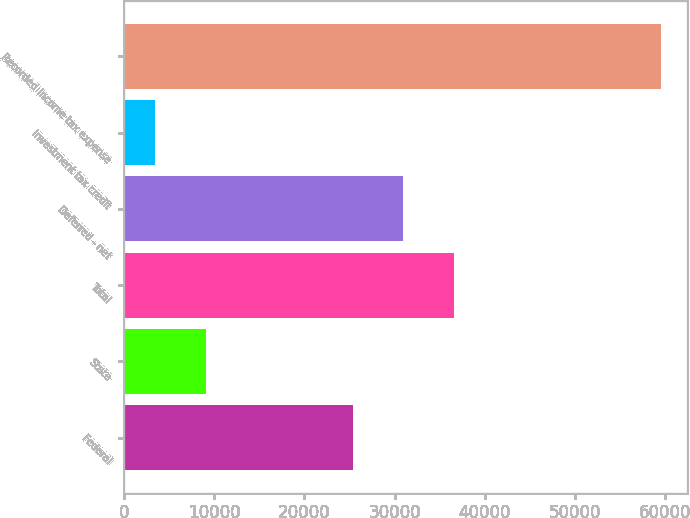Convert chart to OTSL. <chart><loc_0><loc_0><loc_500><loc_500><bar_chart><fcel>Federal<fcel>State<fcel>Total<fcel>Deferred - net<fcel>Investment tax credit<fcel>Recorded income tax expense<nl><fcel>25356<fcel>9081.4<fcel>36558.8<fcel>30957.4<fcel>3480<fcel>59494<nl></chart> 